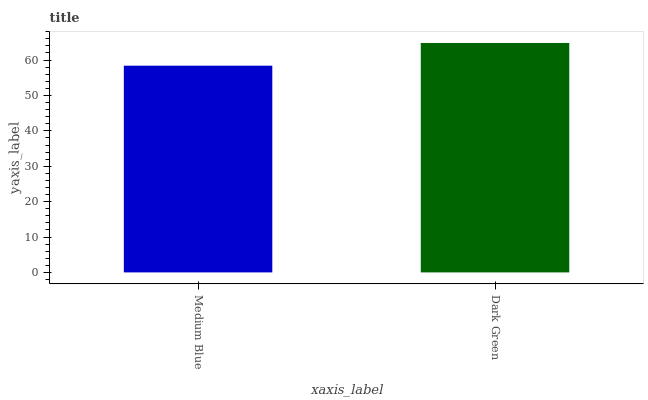Is Medium Blue the minimum?
Answer yes or no. Yes. Is Dark Green the maximum?
Answer yes or no. Yes. Is Dark Green the minimum?
Answer yes or no. No. Is Dark Green greater than Medium Blue?
Answer yes or no. Yes. Is Medium Blue less than Dark Green?
Answer yes or no. Yes. Is Medium Blue greater than Dark Green?
Answer yes or no. No. Is Dark Green less than Medium Blue?
Answer yes or no. No. Is Dark Green the high median?
Answer yes or no. Yes. Is Medium Blue the low median?
Answer yes or no. Yes. Is Medium Blue the high median?
Answer yes or no. No. Is Dark Green the low median?
Answer yes or no. No. 